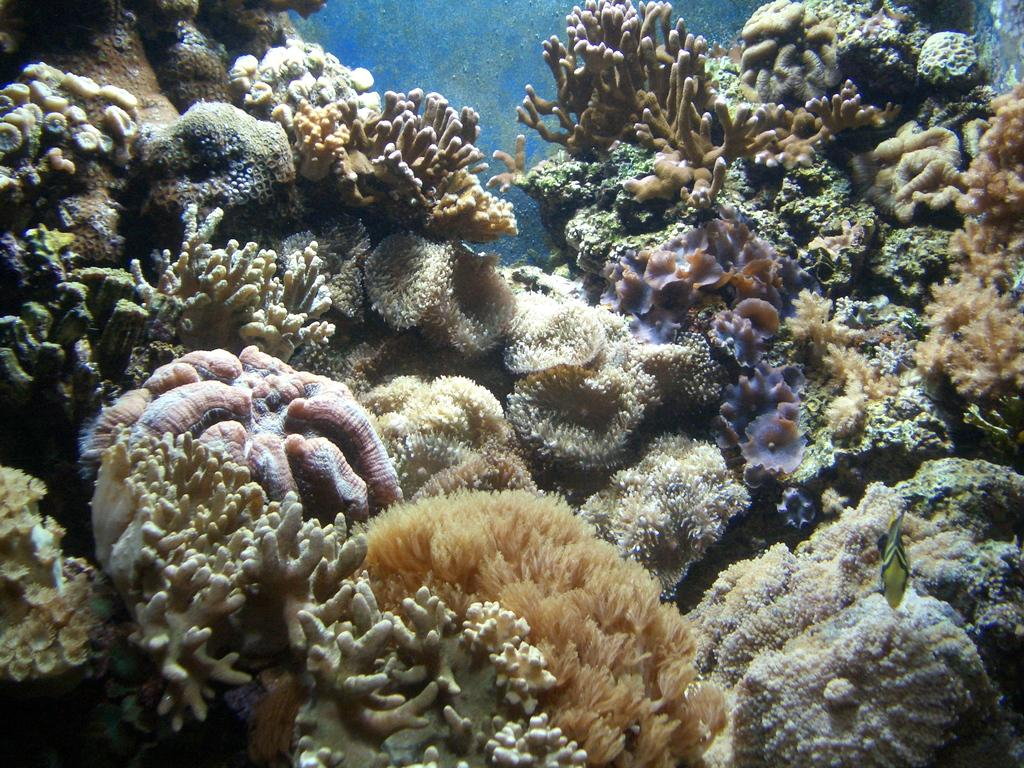What type of underwater environment is depicted in the image? There are coral reefs in the image. What other living organisms can be seen in the image? There are fish in the image. What type of winter clothing is being worn by the fish in the image? There is no winter clothing present in the image, as it features an underwater scene with coral reefs and fish. What type of birthday celebration is taking place in the image? There is no birthday celebration present in the image, as it features an underwater scene with coral reefs and fish. 